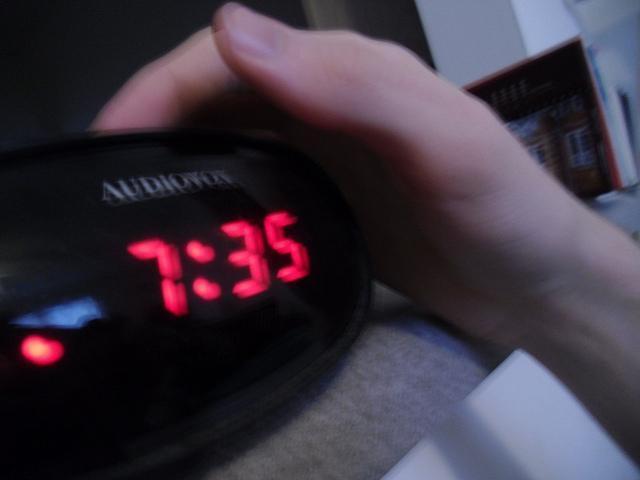How many books are in the picture?
Give a very brief answer. 2. 